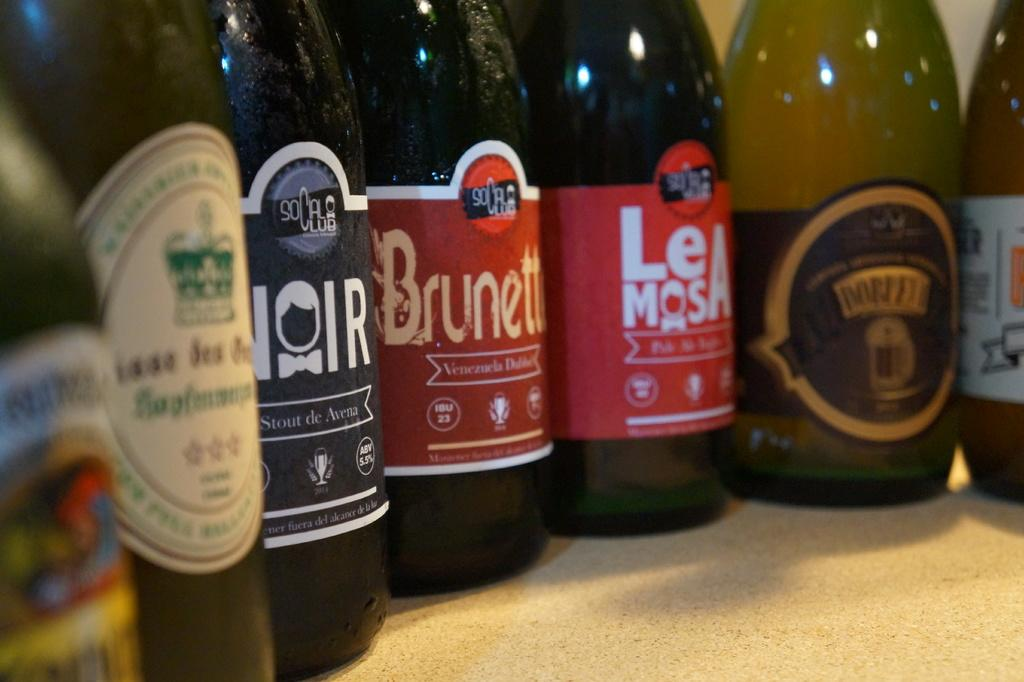<image>
Create a compact narrative representing the image presented. Bottles next to one another with one that says "NOIR" in black. 